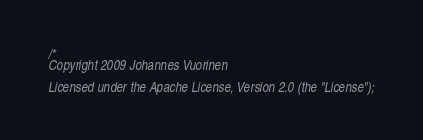<code> <loc_0><loc_0><loc_500><loc_500><_ObjectiveC_>/*
Copyright 2009 Johannes Vuorinen

Licensed under the Apache License, Version 2.0 (the "License");</code> 